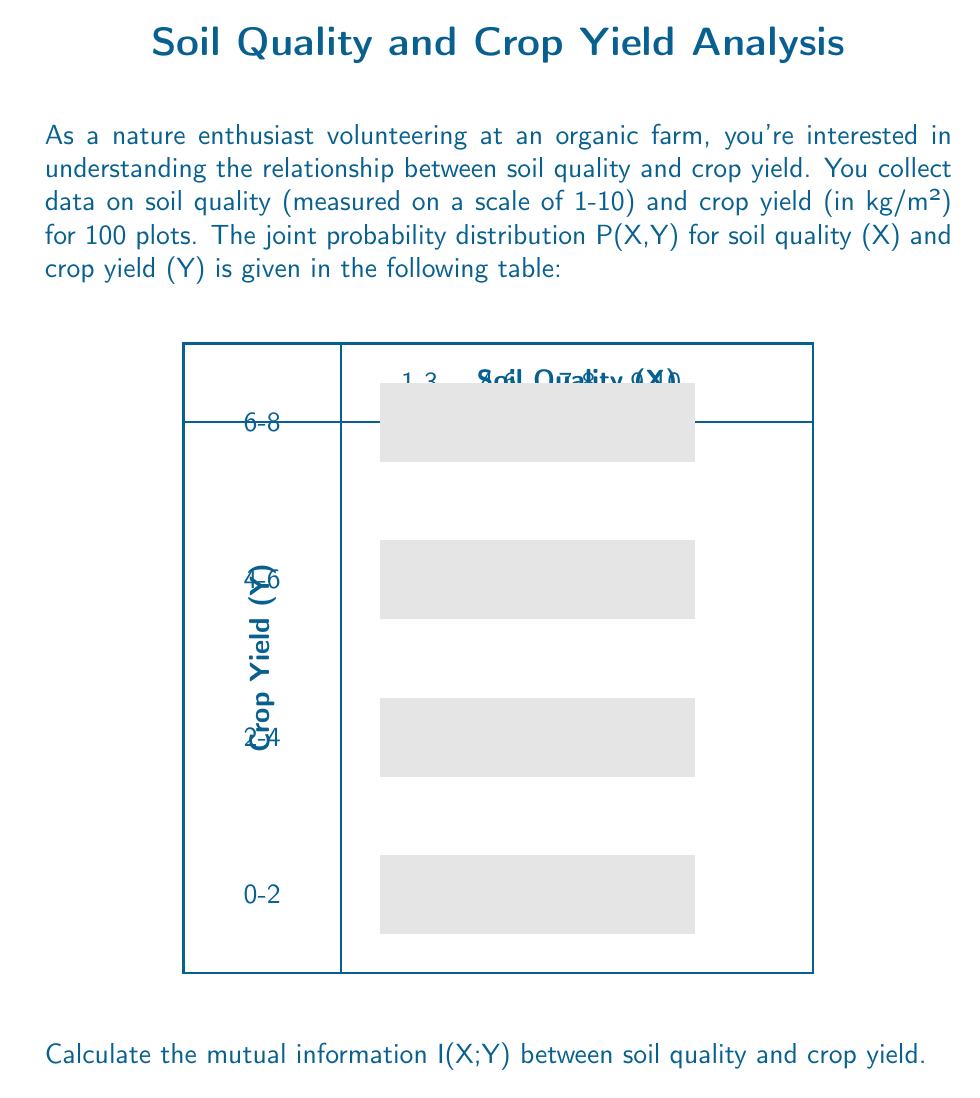Provide a solution to this math problem. To calculate the mutual information I(X;Y), we'll follow these steps:

1) First, we need to calculate the marginal probabilities P(X) and P(Y):

   P(X=1-3) = 0.05 + 0.08 + 0.05 + 0.02 = 0.20
   P(X=4-6) = 0.10 + 0.15 + 0.10 + 0.03 = 0.38
   P(X=7-8) = 0.05 + 0.10 + 0.12 + 0.02 = 0.29
   P(X=9-10) = 0.02 + 0.05 + 0.05 + 0.01 = 0.13

   P(Y=0-2) = 0.05 + 0.10 + 0.05 + 0.02 = 0.22
   P(Y=2-4) = 0.08 + 0.15 + 0.10 + 0.05 = 0.38
   P(Y=4-6) = 0.05 + 0.10 + 0.12 + 0.05 = 0.32
   P(Y=6-8) = 0.02 + 0.03 + 0.02 + 0.01 = 0.08

2) The mutual information is given by:

   $$I(X;Y) = \sum_{x}\sum_{y} P(x,y) \log_2 \frac{P(x,y)}{P(x)P(y)}$$

3) Let's calculate each term:

   0.05 * log2(0.05 / (0.20 * 0.22)) = -0.0358
   0.10 * log2(0.10 / (0.38 * 0.22)) = 0.0305
   0.05 * log2(0.05 / (0.29 * 0.22)) = -0.0216
   0.02 * log2(0.02 / (0.13 * 0.22)) = -0.0068

   0.08 * log2(0.08 / (0.20 * 0.38)) = 0.0305
   0.15 * log2(0.15 / (0.38 * 0.38)) = 0.0386
   0.10 * log2(0.10 / (0.29 * 0.38)) = 0.0305
   0.05 * log2(0.05 / (0.13 * 0.38)) = 0.0216

   0.05 * log2(0.05 / (0.20 * 0.32)) = -0.0216
   0.10 * log2(0.10 / (0.38 * 0.32)) = 0.0139
   0.12 * log2(0.12 / (0.29 * 0.32)) = 0.0574
   0.05 * log2(0.05 / (0.13 * 0.32)) = 0.0305

   0.02 * log2(0.02 / (0.20 * 0.08)) = 0.0139
   0.03 * log2(0.03 / (0.38 * 0.08)) = 0.0166
   0.02 * log2(0.02 / (0.29 * 0.08)) = 0.0078
   0.01 * log2(0.01 / (0.13 * 0.08)) = 0.0027

4) Sum all these terms:

   I(X;Y) = 0.2087 bits
Answer: 0.2087 bits 